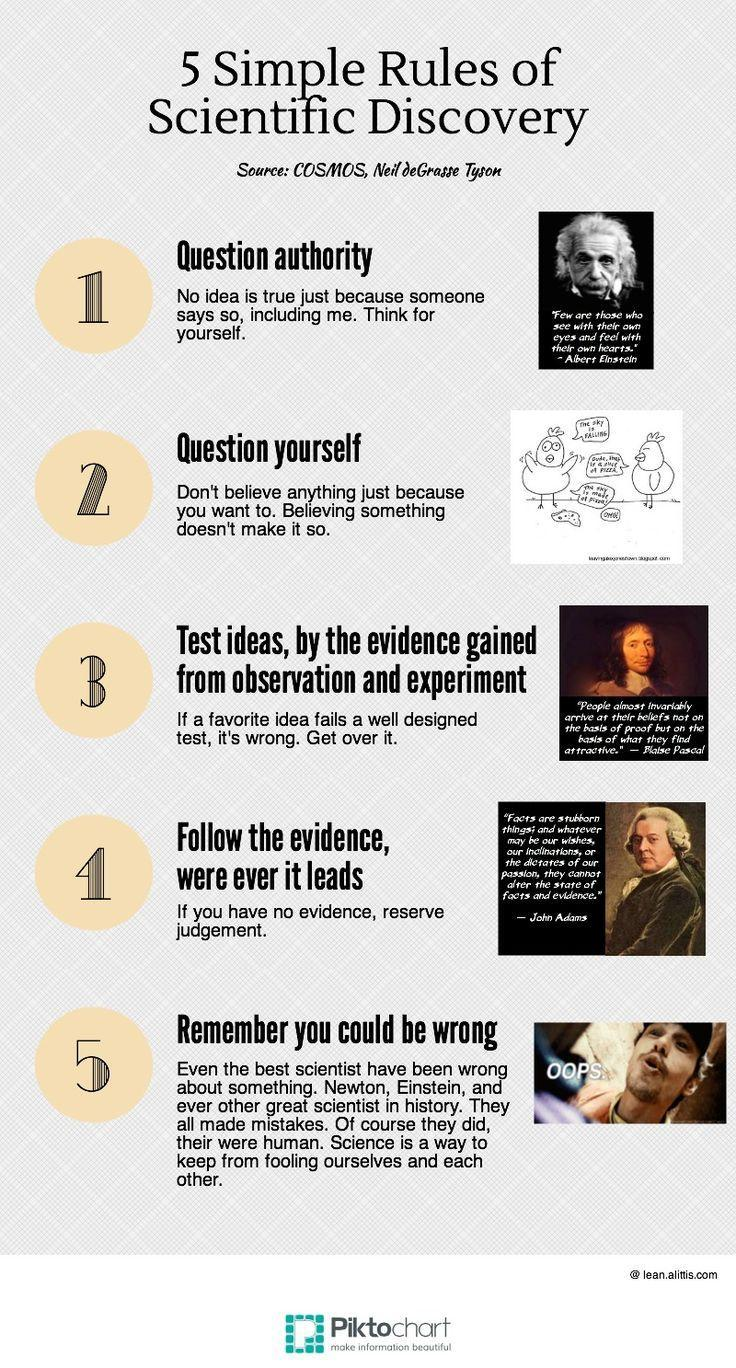Which is the French mathematicians image is displayed in the document, Albert Einstein, Blaise Pascal, or John Adams?
Answer the question with a short phrase. Blaise Pascal 